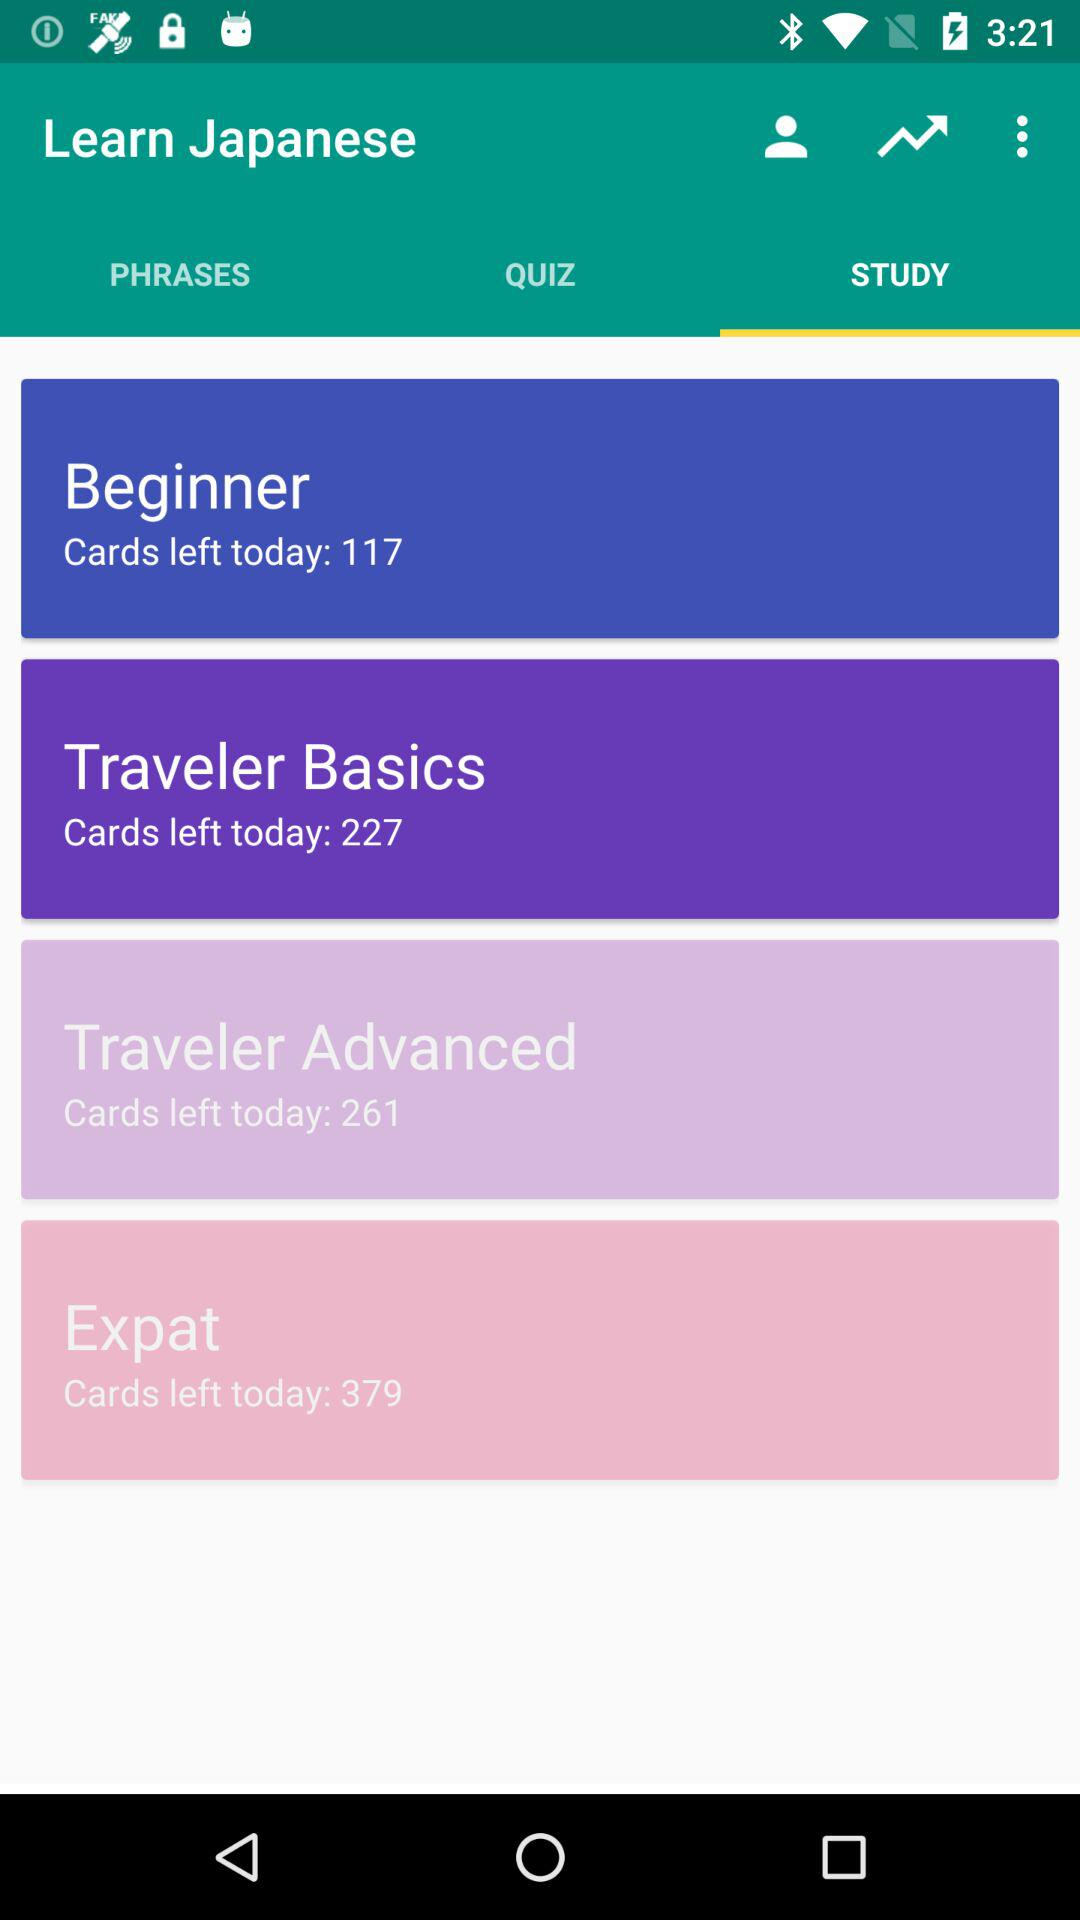How many quizzes have been completed?
When the provided information is insufficient, respond with <no answer>. <no answer> 